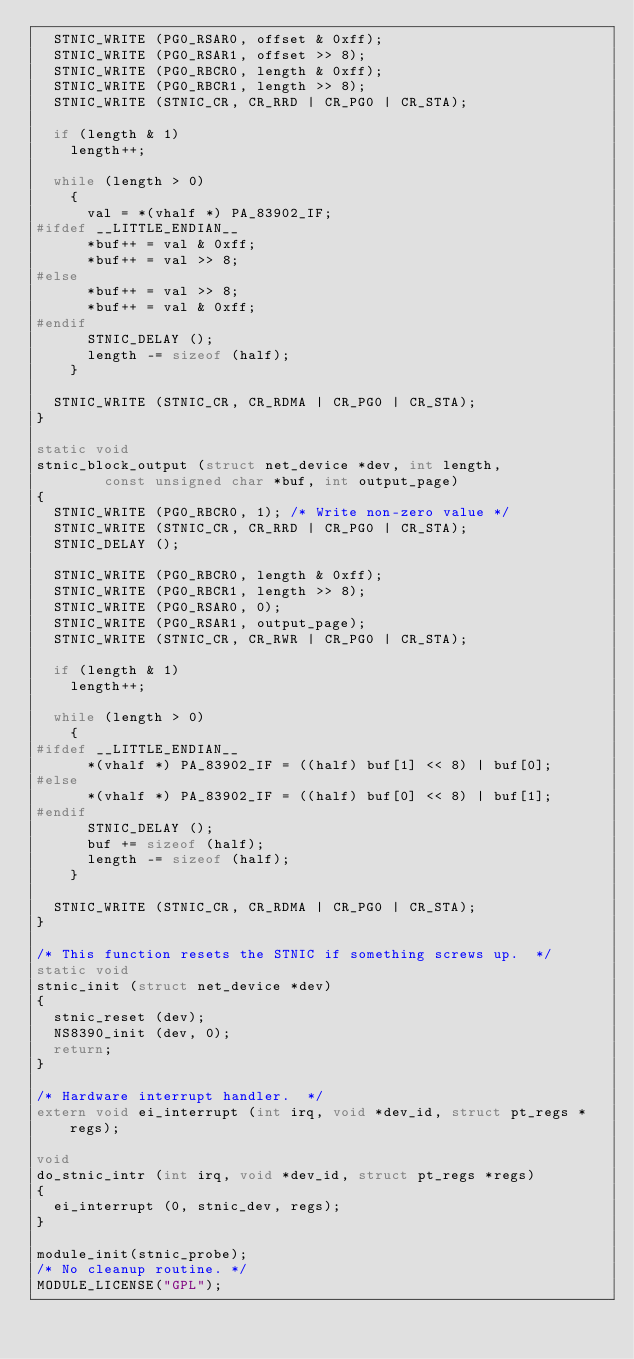<code> <loc_0><loc_0><loc_500><loc_500><_C_>  STNIC_WRITE (PG0_RSAR0, offset & 0xff);
  STNIC_WRITE (PG0_RSAR1, offset >> 8);
  STNIC_WRITE (PG0_RBCR0, length & 0xff);
  STNIC_WRITE (PG0_RBCR1, length >> 8);
  STNIC_WRITE (STNIC_CR, CR_RRD | CR_PG0 | CR_STA);

  if (length & 1)
    length++;

  while (length > 0)
    {
      val = *(vhalf *) PA_83902_IF;
#ifdef __LITTLE_ENDIAN__
      *buf++ = val & 0xff;
      *buf++ = val >> 8;
#else
      *buf++ = val >> 8;
      *buf++ = val & 0xff;
#endif
      STNIC_DELAY ();
      length -= sizeof (half);
    }

  STNIC_WRITE (STNIC_CR, CR_RDMA | CR_PG0 | CR_STA);
}

static void
stnic_block_output (struct net_device *dev, int length,
		    const unsigned char *buf, int output_page)
{
  STNIC_WRITE (PG0_RBCR0, 1);	/* Write non-zero value */
  STNIC_WRITE (STNIC_CR, CR_RRD | CR_PG0 | CR_STA);
  STNIC_DELAY ();

  STNIC_WRITE (PG0_RBCR0, length & 0xff);
  STNIC_WRITE (PG0_RBCR1, length >> 8);
  STNIC_WRITE (PG0_RSAR0, 0);
  STNIC_WRITE (PG0_RSAR1, output_page);
  STNIC_WRITE (STNIC_CR, CR_RWR | CR_PG0 | CR_STA);

  if (length & 1)
    length++;

  while (length > 0)
    {
#ifdef __LITTLE_ENDIAN__
      *(vhalf *) PA_83902_IF = ((half) buf[1] << 8) | buf[0];
#else
      *(vhalf *) PA_83902_IF = ((half) buf[0] << 8) | buf[1];
#endif
      STNIC_DELAY ();
      buf += sizeof (half);
      length -= sizeof (half);
    }

  STNIC_WRITE (STNIC_CR, CR_RDMA | CR_PG0 | CR_STA);
}

/* This function resets the STNIC if something screws up.  */
static void
stnic_init (struct net_device *dev)
{
  stnic_reset (dev);
  NS8390_init (dev, 0);
  return;
}

/* Hardware interrupt handler.  */
extern void ei_interrupt (int irq, void *dev_id, struct pt_regs *regs);

void
do_stnic_intr (int irq, void *dev_id, struct pt_regs *regs)
{
  ei_interrupt (0, stnic_dev, regs);
}

module_init(stnic_probe);
/* No cleanup routine. */
MODULE_LICENSE("GPL");
</code> 